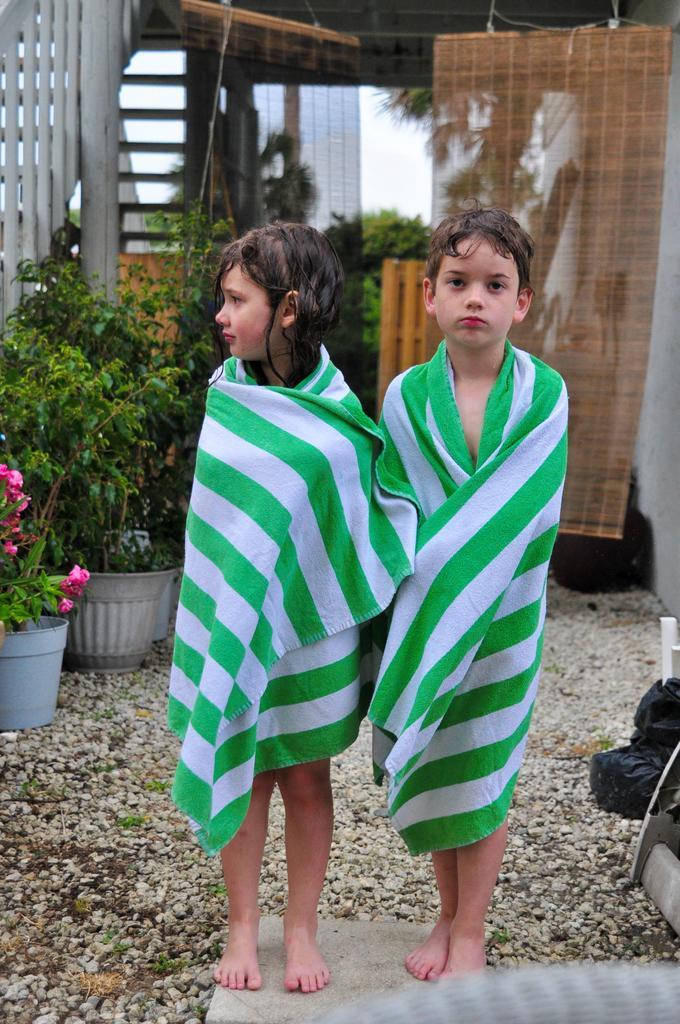Describe this image in one or two sentences. In this image we can see two children standing on the marble covering their body with the towels. On the backside we can see some stones, plants in a pot, stairs, bamboo sheet and windows. 